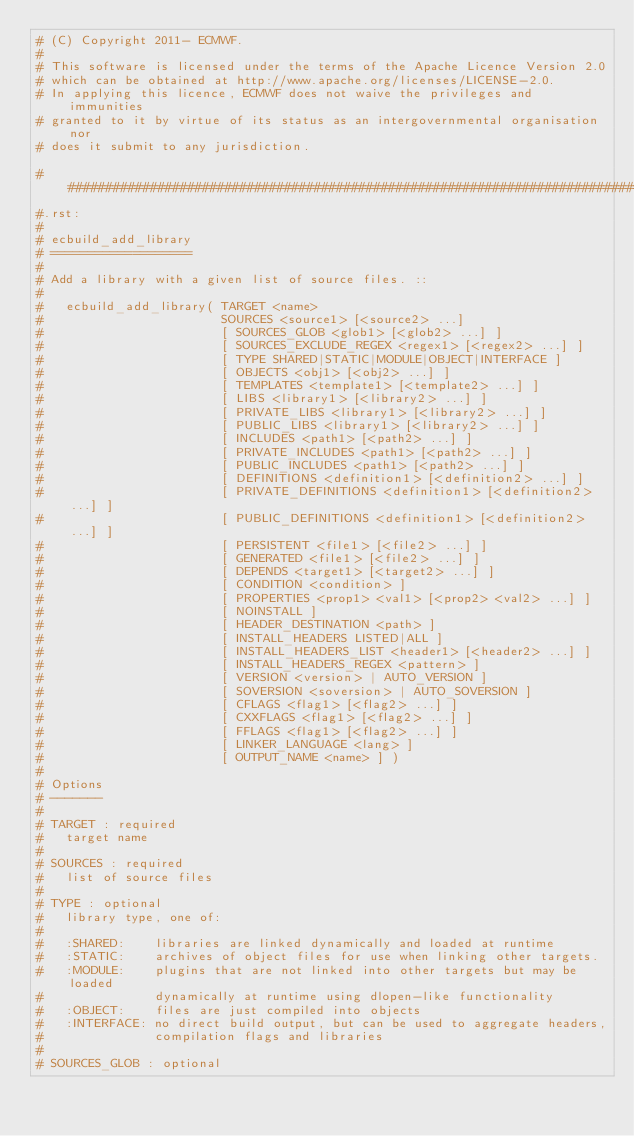<code> <loc_0><loc_0><loc_500><loc_500><_CMake_># (C) Copyright 2011- ECMWF.
#
# This software is licensed under the terms of the Apache Licence Version 2.0
# which can be obtained at http://www.apache.org/licenses/LICENSE-2.0.
# In applying this licence, ECMWF does not waive the privileges and immunities
# granted to it by virtue of its status as an intergovernmental organisation nor
# does it submit to any jurisdiction.

##############################################################################
#.rst:
#
# ecbuild_add_library
# ===================
#
# Add a library with a given list of source files. ::
#
#   ecbuild_add_library( TARGET <name>
#                        SOURCES <source1> [<source2> ...]
#                        [ SOURCES_GLOB <glob1> [<glob2> ...] ]
#                        [ SOURCES_EXCLUDE_REGEX <regex1> [<regex2> ...] ]
#                        [ TYPE SHARED|STATIC|MODULE|OBJECT|INTERFACE ]
#                        [ OBJECTS <obj1> [<obj2> ...] ]
#                        [ TEMPLATES <template1> [<template2> ...] ]
#                        [ LIBS <library1> [<library2> ...] ]
#                        [ PRIVATE_LIBS <library1> [<library2> ...] ]
#                        [ PUBLIC_LIBS <library1> [<library2> ...] ]
#                        [ INCLUDES <path1> [<path2> ...] ]
#                        [ PRIVATE_INCLUDES <path1> [<path2> ...] ]
#                        [ PUBLIC_INCLUDES <path1> [<path2> ...] ]
#                        [ DEFINITIONS <definition1> [<definition2> ...] ]
#                        [ PRIVATE_DEFINITIONS <definition1> [<definition2> ...] ]
#                        [ PUBLIC_DEFINITIONS <definition1> [<definition2> ...] ]
#                        [ PERSISTENT <file1> [<file2> ...] ]
#                        [ GENERATED <file1> [<file2> ...] ]
#                        [ DEPENDS <target1> [<target2> ...] ]
#                        [ CONDITION <condition> ]
#                        [ PROPERTIES <prop1> <val1> [<prop2> <val2> ...] ]
#                        [ NOINSTALL ]
#                        [ HEADER_DESTINATION <path> ]
#                        [ INSTALL_HEADERS LISTED|ALL ]
#                        [ INSTALL_HEADERS_LIST <header1> [<header2> ...] ]
#                        [ INSTALL_HEADERS_REGEX <pattern> ]
#                        [ VERSION <version> | AUTO_VERSION ]
#                        [ SOVERSION <soversion> | AUTO_SOVERSION ]
#                        [ CFLAGS <flag1> [<flag2> ...] ]
#                        [ CXXFLAGS <flag1> [<flag2> ...] ]
#                        [ FFLAGS <flag1> [<flag2> ...] ]
#                        [ LINKER_LANGUAGE <lang> ]
#                        [ OUTPUT_NAME <name> ] )
#
# Options
# -------
#
# TARGET : required
#   target name
#
# SOURCES : required
#   list of source files
#
# TYPE : optional
#   library type, one of:
#
#   :SHARED:    libraries are linked dynamically and loaded at runtime
#   :STATIC:    archives of object files for use when linking other targets.
#   :MODULE:    plugins that are not linked into other targets but may be loaded
#               dynamically at runtime using dlopen-like functionality
#   :OBJECT:    files are just compiled into objects
#   :INTERFACE: no direct build output, but can be used to aggregate headers,
#               compilation flags and libraries
#
# SOURCES_GLOB : optional</code> 